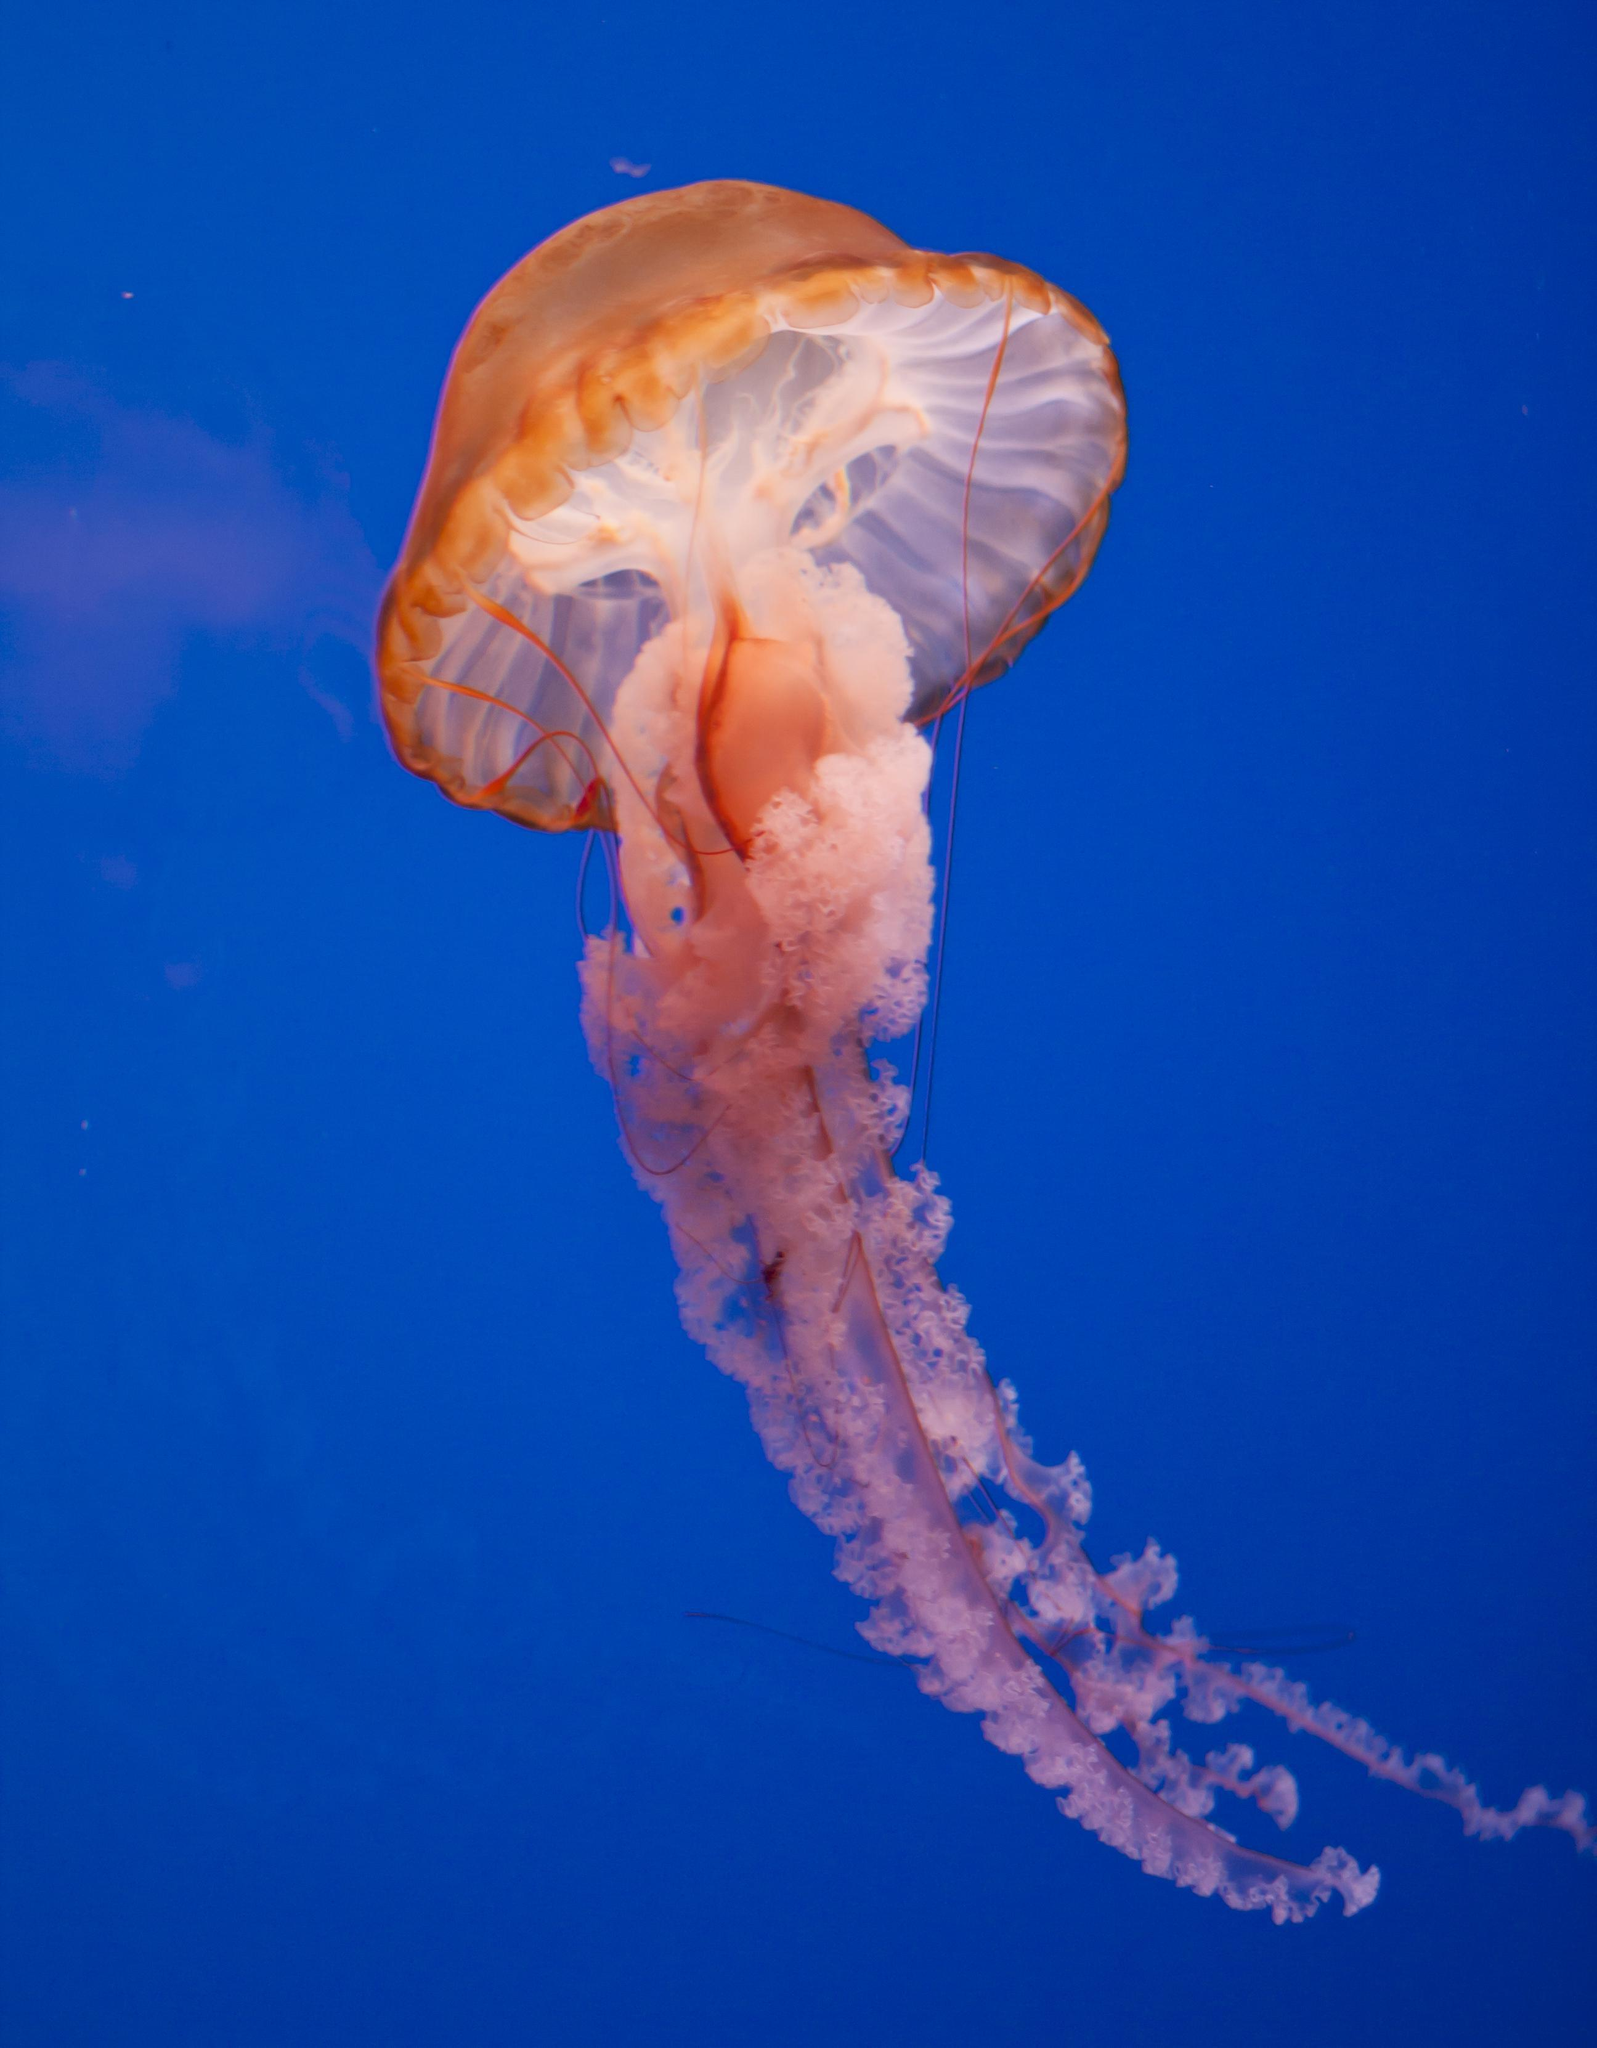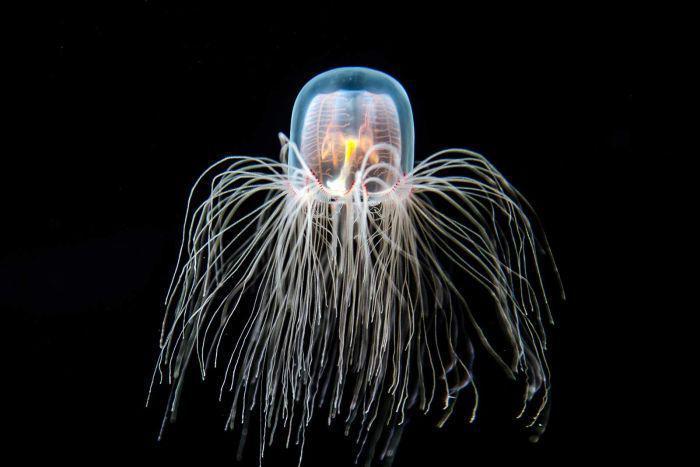The first image is the image on the left, the second image is the image on the right. Analyze the images presented: Is the assertion "a jealyfish is pictured against a black background." valid? Answer yes or no. Yes. 